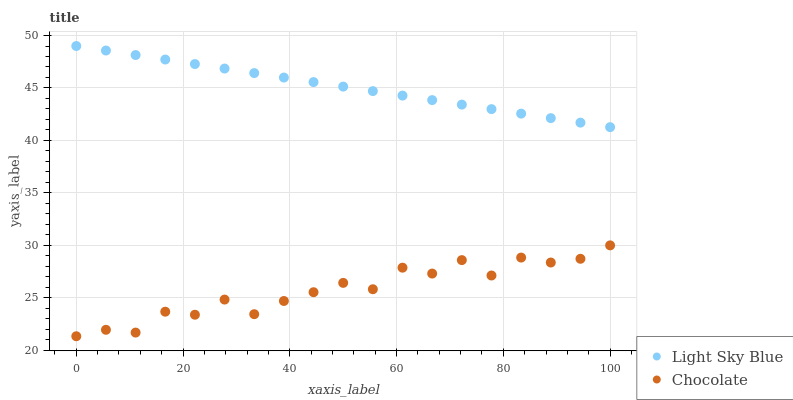Does Chocolate have the minimum area under the curve?
Answer yes or no. Yes. Does Light Sky Blue have the maximum area under the curve?
Answer yes or no. Yes. Does Chocolate have the maximum area under the curve?
Answer yes or no. No. Is Light Sky Blue the smoothest?
Answer yes or no. Yes. Is Chocolate the roughest?
Answer yes or no. Yes. Is Chocolate the smoothest?
Answer yes or no. No. Does Chocolate have the lowest value?
Answer yes or no. Yes. Does Light Sky Blue have the highest value?
Answer yes or no. Yes. Does Chocolate have the highest value?
Answer yes or no. No. Is Chocolate less than Light Sky Blue?
Answer yes or no. Yes. Is Light Sky Blue greater than Chocolate?
Answer yes or no. Yes. Does Chocolate intersect Light Sky Blue?
Answer yes or no. No. 